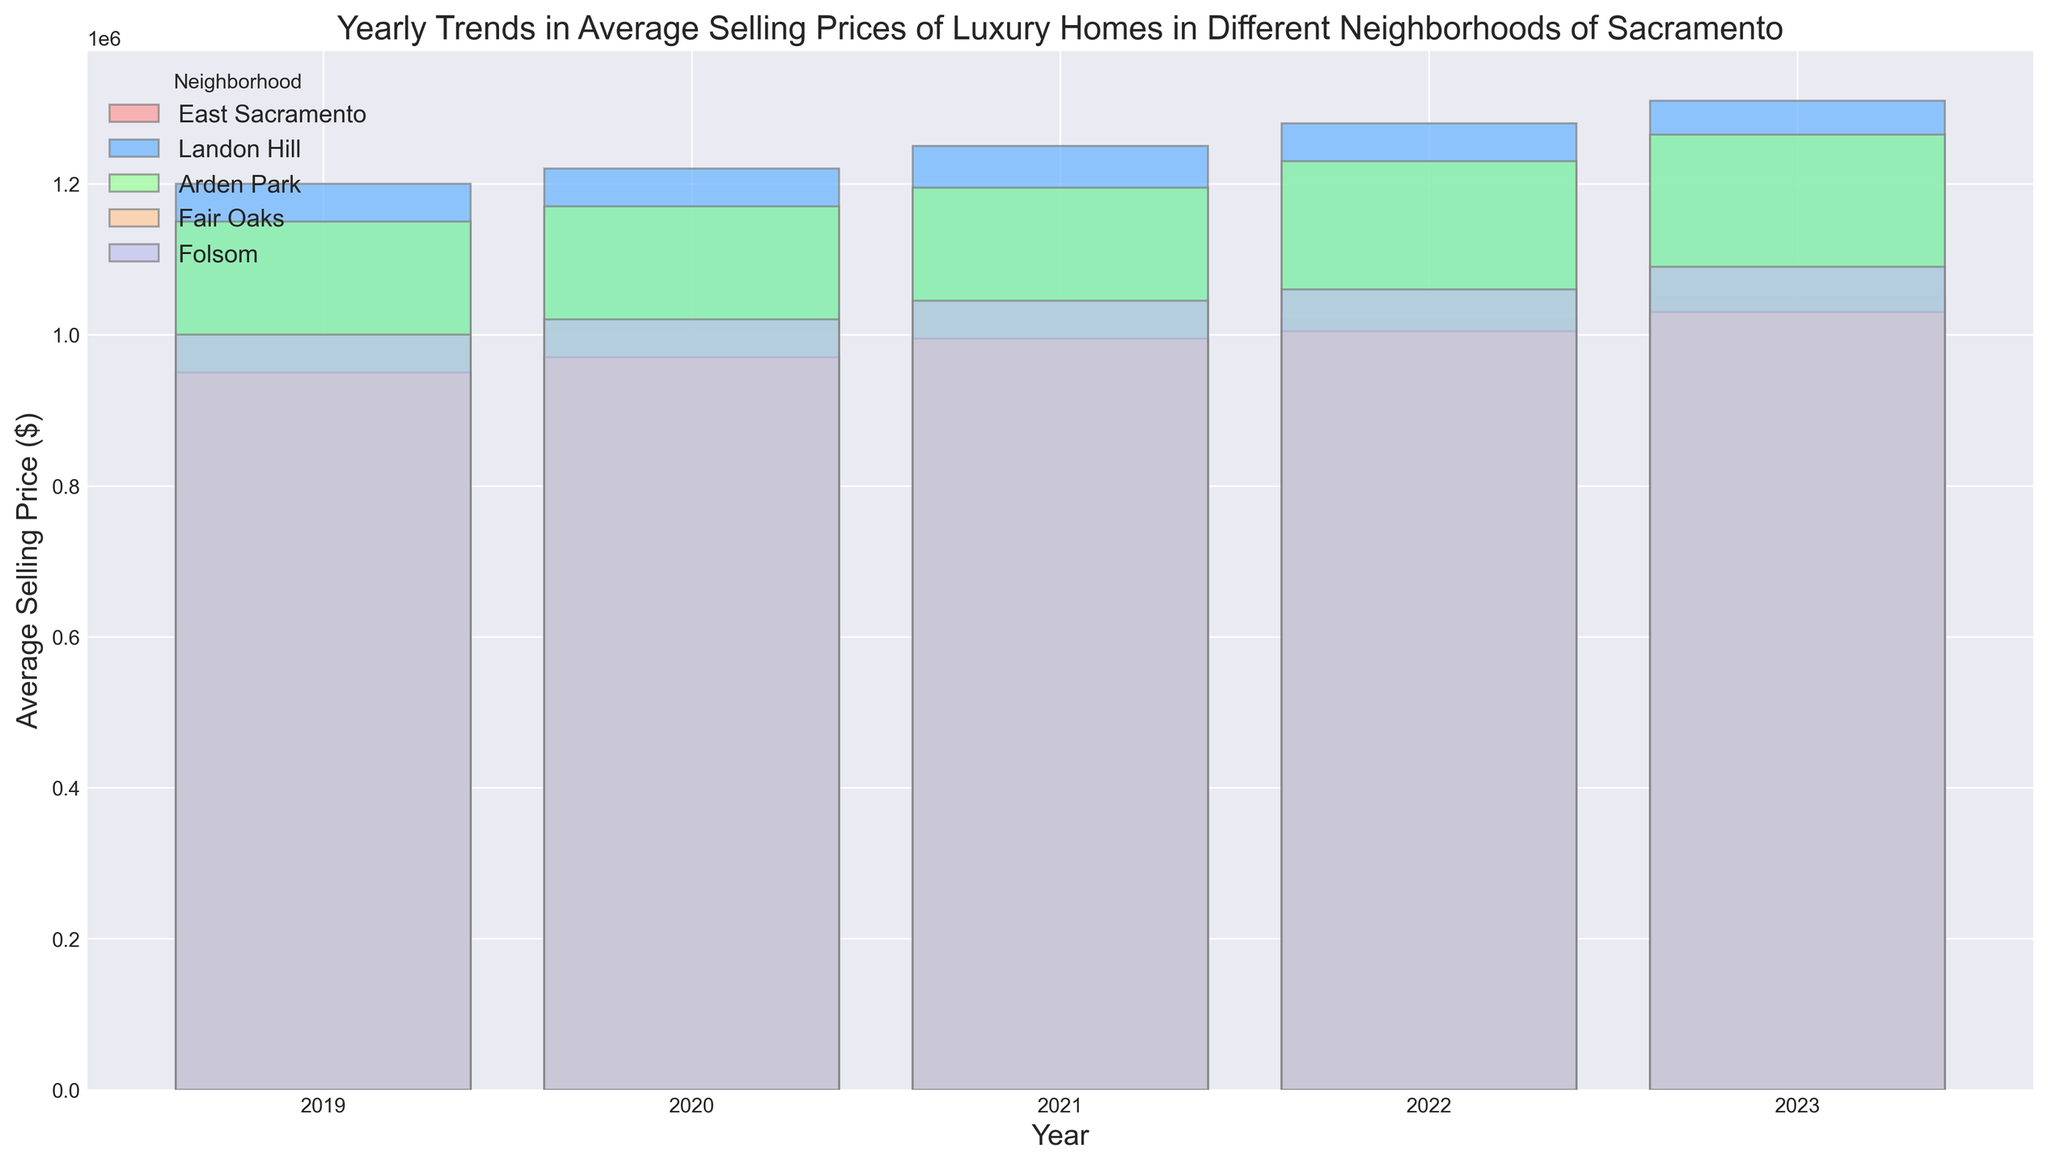Which neighborhood had the highest average selling price in 2023? Look for the tallest bar in 2023. The neighborhood with the highest average selling price in 2023 is Landon Hill.
Answer: Landon Hill How did the average selling price in East Sacramento change from 2019 to 2023? To find the change, we subtract the 2019 average selling price from the 2023 average selling price for East Sacramento. In 2019, the price was $950,000 and in 2023, it was $1,050,000. The change is $1,050,000 - $950,000 = $100,000.
Answer: $100,000 In which year did Fair Oaks see its lowest average selling price? Find the shortest bar for Fair Oaks. The shortest bar for Fair Oaks corresponds to the year 2019.
Answer: 2019 What is the difference in the average selling price between Arden Park and Folsom in 2021? Compare the heights of the bars for Arden Park and Folsom in 2021. Arden Park had an average price of $1,195,000, and Folsom had $1,045,000. The difference is $1,195,000 - $1,045,000 = $150,000.
Answer: $150,000 Which neighborhood consistently increased in average selling price each year from 2019 to 2023? Check the trend of bars for each neighborhood from 2019 to 2023. Landon Hill's bars consistently increase each year from 2019 to 2023.
Answer: Landon Hill What was the average selling price of Fair Oaks in 2020 and how does it compare to Folsom in the same year? Look for the bar heights of Fair Oaks and Folsom in 2020. Fair Oaks had an average selling price of $970,000 and Folsom had $1,020,000. Fair Oaks is $50,000 less than Folsom.
Answer: Fair Oaks: $970,000, $50,000 less than Folsom What is the overall trend observed in the average selling prices of luxury homes in East Sacramento from 2019 to 2023? Observe the general direction of the bars for East Sacramento from 2019 to 2023. The trend shows a gradual increase each year.
Answer: Increasing Which neighborhood experienced the smallest increase in average selling price from 2021 to 2022? Calculate the increases for each neighborhood from 2021 to 2022 and compare. East Sacramento increased $25,000, Landon Hill $30,000, Arden Park $35,000, Fair Oaks $10,000, and Folsom $15,000. Fair Oaks had the smallest increase.
Answer: Fair Oaks ($10,000) How do the 2023 average selling prices of East Sacramento and Arden Park compare? Compare the heights of the bars for East Sacramento and Arden Park in 2023. East Sacramento's price is $1,050,000 and Arden Park's is $1,265,000. Arden Park's price is higher.
Answer: Arden Park is higher What's the increase in average selling price for Folsom from 2019 to 2023? Subtract the 2019 average selling price from the 2023 price for Folsom. In 2019, it was $1,000,000, and in 2023, it was $1,090,000. The increase is $1,090,000 - $1,000,000 = $90,000.
Answer: $90,000 